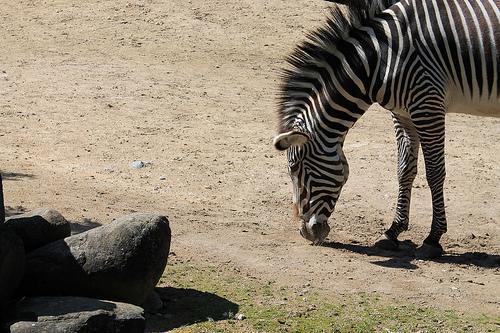How many zebras are pictured?
Give a very brief answer. 1. 